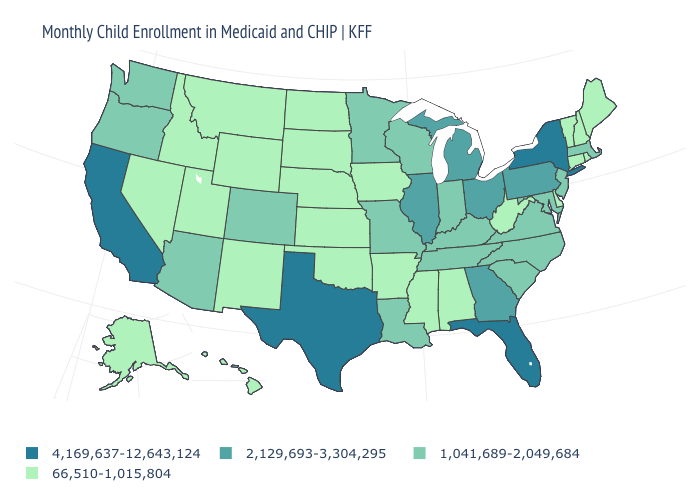Is the legend a continuous bar?
Keep it brief. No. Which states hav the highest value in the MidWest?
Write a very short answer. Illinois, Michigan, Ohio. Which states have the lowest value in the USA?
Concise answer only. Alabama, Alaska, Arkansas, Connecticut, Delaware, Hawaii, Idaho, Iowa, Kansas, Maine, Mississippi, Montana, Nebraska, Nevada, New Hampshire, New Mexico, North Dakota, Oklahoma, Rhode Island, South Dakota, Utah, Vermont, West Virginia, Wyoming. Does New York have the same value as West Virginia?
Write a very short answer. No. Is the legend a continuous bar?
Quick response, please. No. Among the states that border California , does Nevada have the lowest value?
Quick response, please. Yes. Does Arizona have the lowest value in the USA?
Concise answer only. No. What is the value of Arkansas?
Write a very short answer. 66,510-1,015,804. Among the states that border California , does Nevada have the highest value?
Answer briefly. No. Name the states that have a value in the range 66,510-1,015,804?
Short answer required. Alabama, Alaska, Arkansas, Connecticut, Delaware, Hawaii, Idaho, Iowa, Kansas, Maine, Mississippi, Montana, Nebraska, Nevada, New Hampshire, New Mexico, North Dakota, Oklahoma, Rhode Island, South Dakota, Utah, Vermont, West Virginia, Wyoming. What is the lowest value in the West?
Quick response, please. 66,510-1,015,804. Among the states that border Arizona , which have the highest value?
Answer briefly. California. What is the value of Illinois?
Concise answer only. 2,129,693-3,304,295. Does Alabama have a higher value than Illinois?
Quick response, please. No. Does the first symbol in the legend represent the smallest category?
Short answer required. No. 